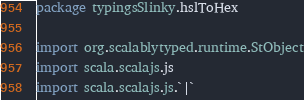<code> <loc_0><loc_0><loc_500><loc_500><_Scala_>package typingsSlinky.hslToHex

import org.scalablytyped.runtime.StObject
import scala.scalajs.js
import scala.scalajs.js.`|`</code> 